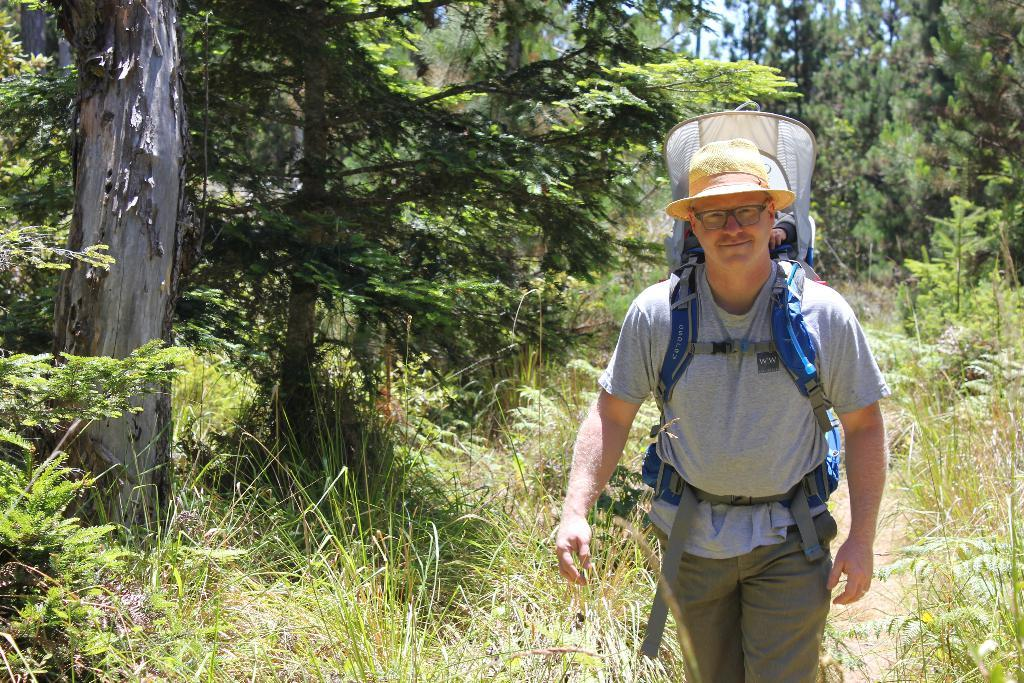What type of vegetation can be seen in the image? There are trees in the image. What else can be seen on the ground in the image? There is grass visible in the image. What is the person wearing in the image? One person is wearing a bag in the image. What is the person doing in the image? The person is walking. What type of music can be heard playing in the background of the image? There is no music present in the image, as it is a still photograph. What action is the spade performing in the image? There is no spade present in the image. 